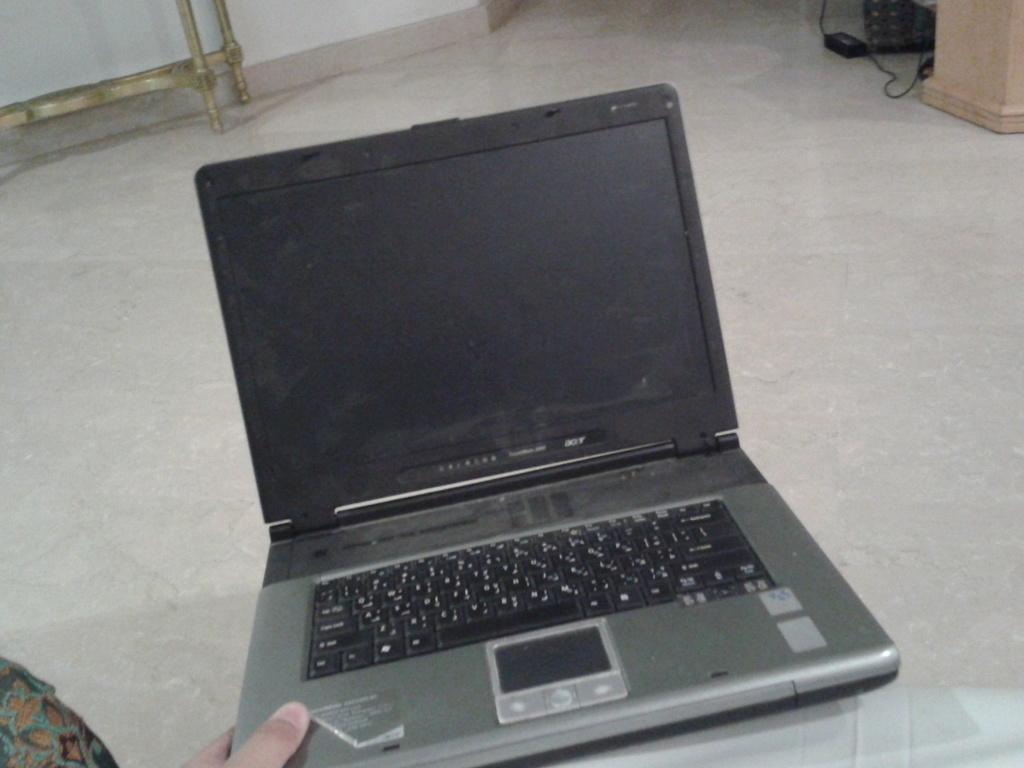What is the human hand holding in the image? There is a human hand holding a laptop in the image. What part of the room can be seen in the image? The floor is visible in the image. Can you identify any furniture in the image? There appears to be a table in the top left corner of the image. What statement does the laptop make about the rate of airplane travel in the image? There is no information about airplane travel or any statements made by the laptop in the image. 